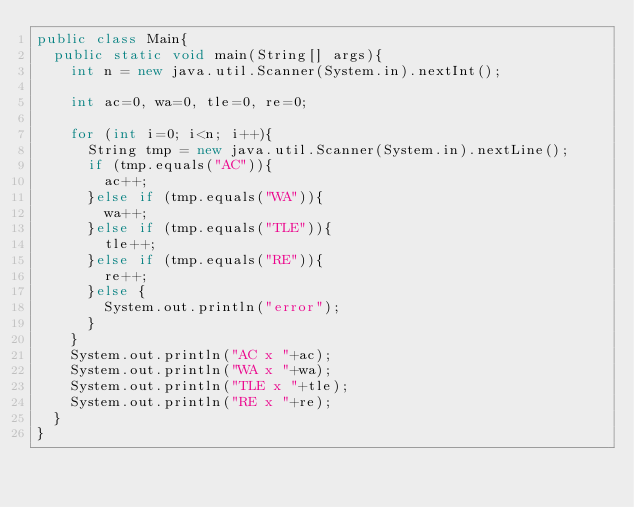<code> <loc_0><loc_0><loc_500><loc_500><_Java_>public class Main{
  public static void main(String[] args){
    int n = new java.util.Scanner(System.in).nextInt();

    int ac=0, wa=0, tle=0, re=0;

    for (int i=0; i<n; i++){
      String tmp = new java.util.Scanner(System.in).nextLine();
      if (tmp.equals("AC")){
        ac++;
      }else if (tmp.equals("WA")){
        wa++;
      }else if (tmp.equals("TLE")){
        tle++;
      }else if (tmp.equals("RE")){
        re++;
      }else {
        System.out.println("error");
      }
    }
    System.out.println("AC x "+ac);
    System.out.println("WA x "+wa);
    System.out.println("TLE x "+tle);
    System.out.println("RE x "+re);
  }
}
</code> 